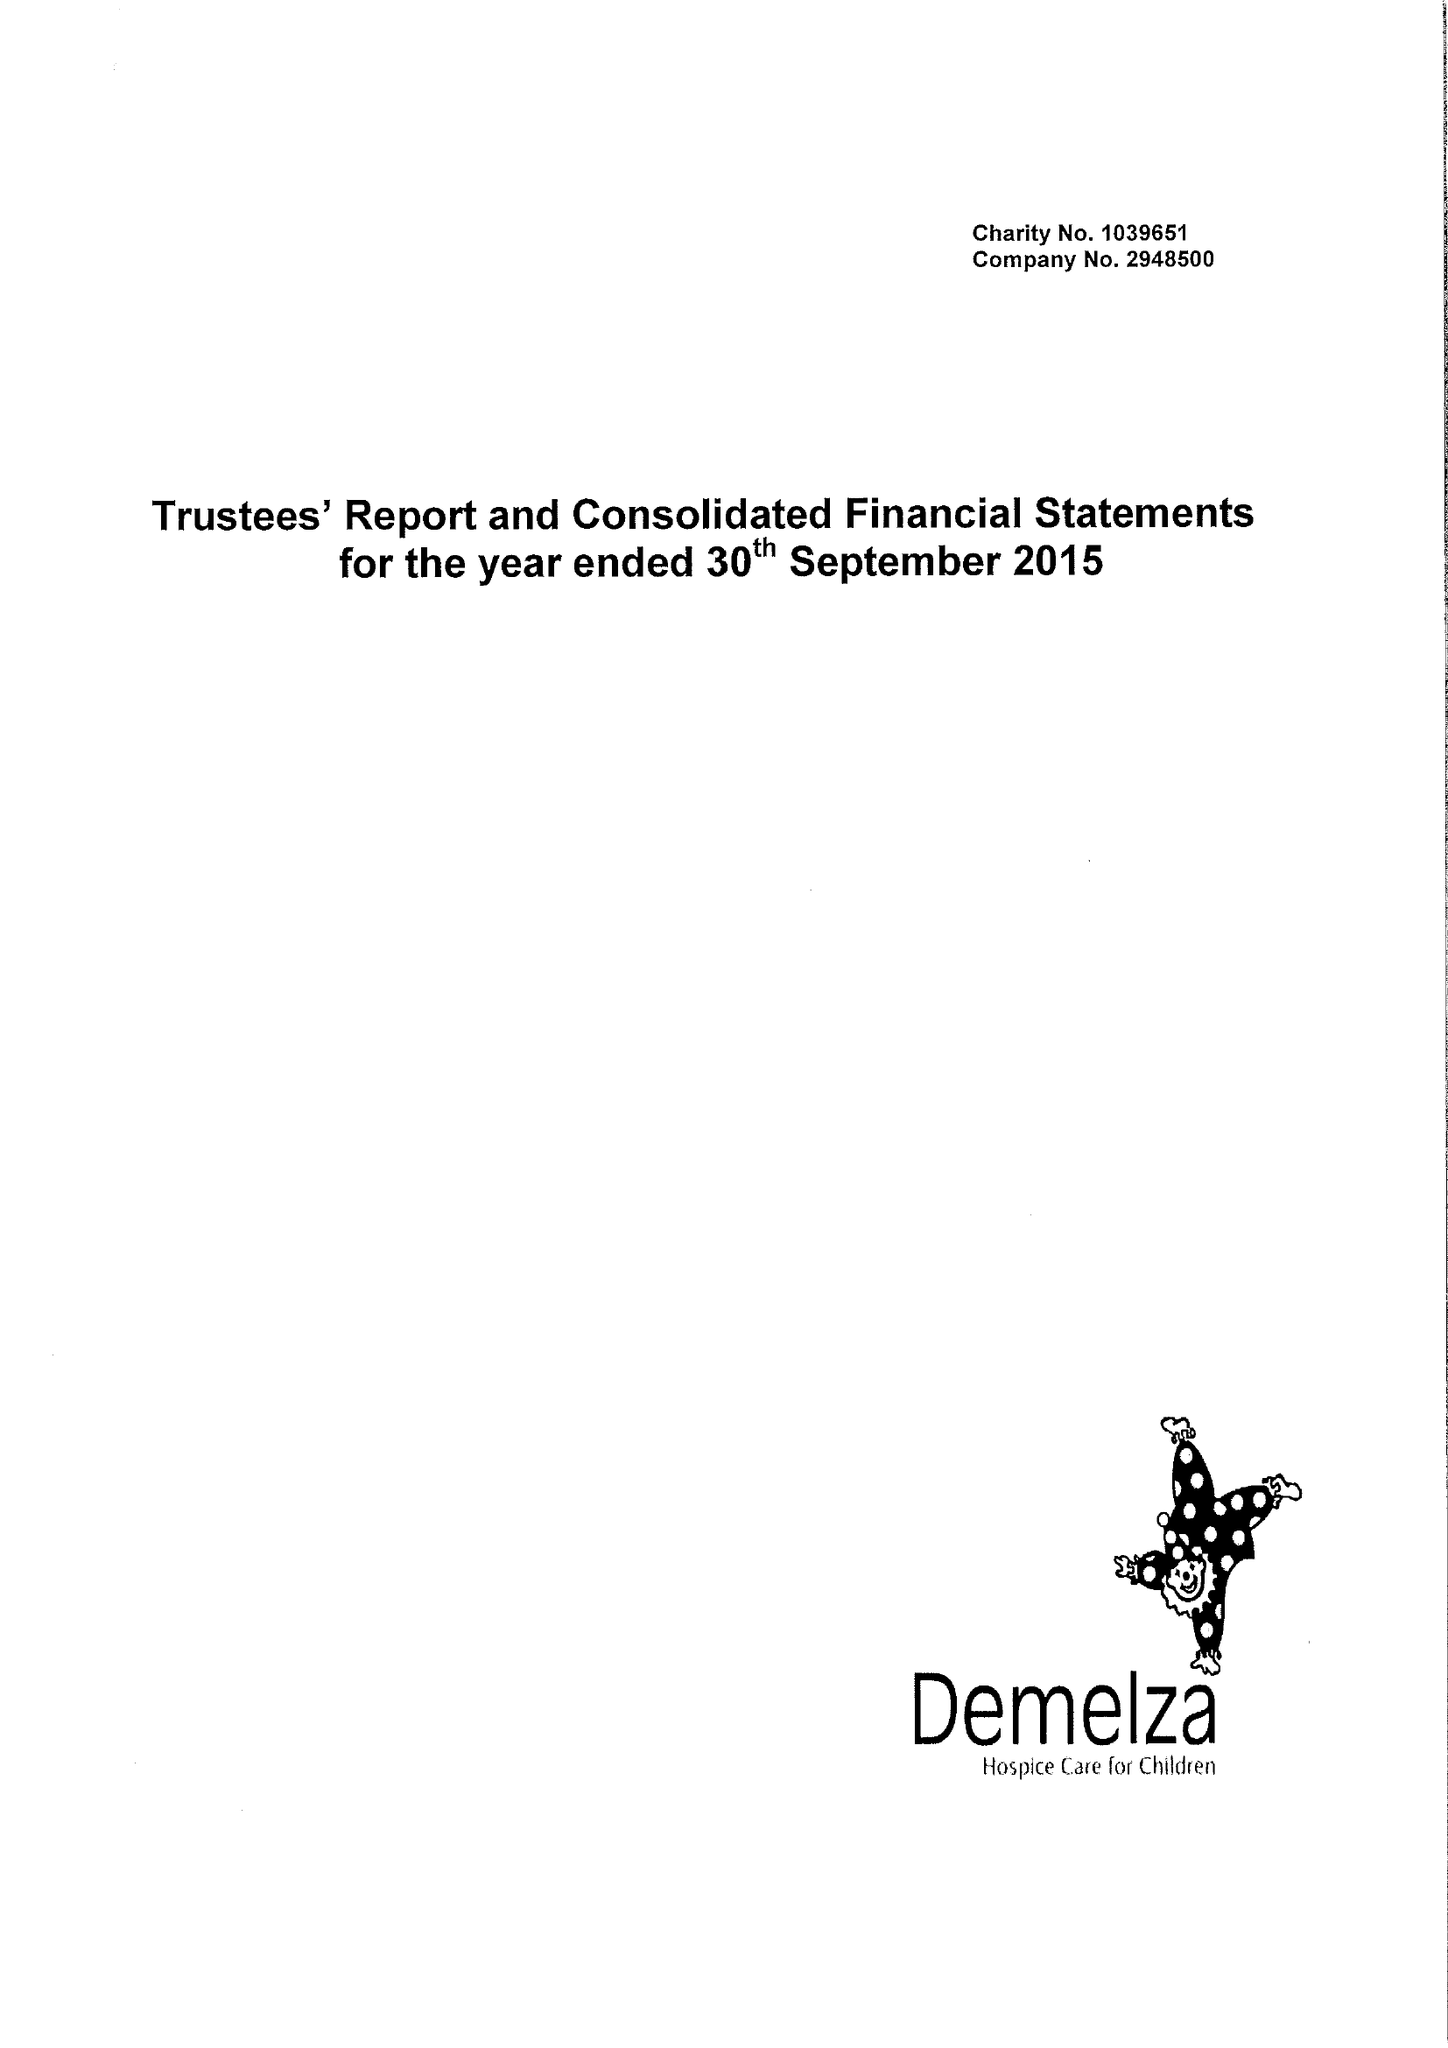What is the value for the charity_number?
Answer the question using a single word or phrase. 1039651 